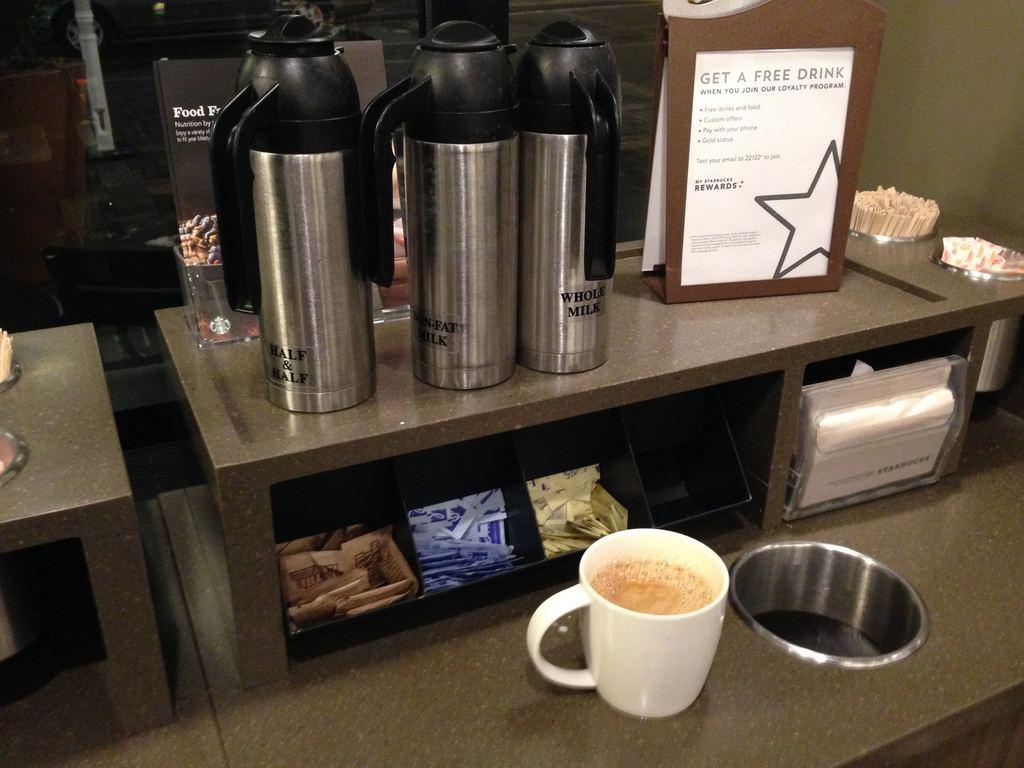<image>
Provide a brief description of the given image. A sign that reads "get a free drink" is next to various milk cannisters and sugar packets. 